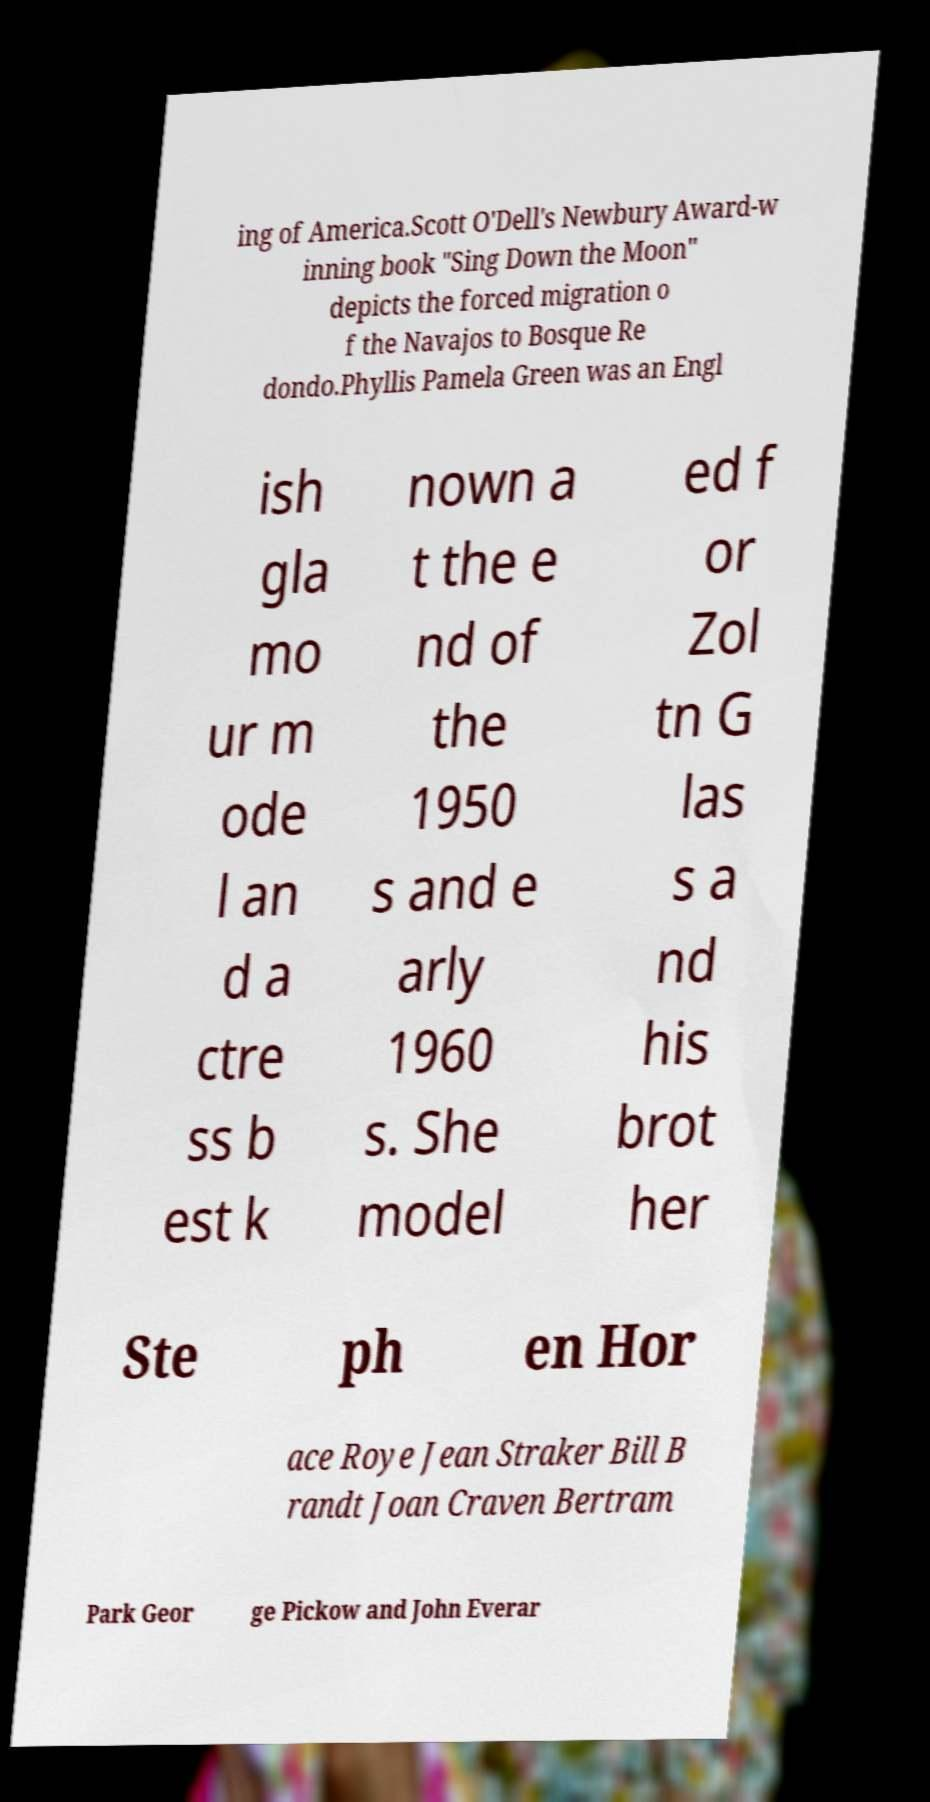Please read and relay the text visible in this image. What does it say? ing of America.Scott O'Dell's Newbury Award-w inning book "Sing Down the Moon" depicts the forced migration o f the Navajos to Bosque Re dondo.Phyllis Pamela Green was an Engl ish gla mo ur m ode l an d a ctre ss b est k nown a t the e nd of the 1950 s and e arly 1960 s. She model ed f or Zol tn G las s a nd his brot her Ste ph en Hor ace Roye Jean Straker Bill B randt Joan Craven Bertram Park Geor ge Pickow and John Everar 